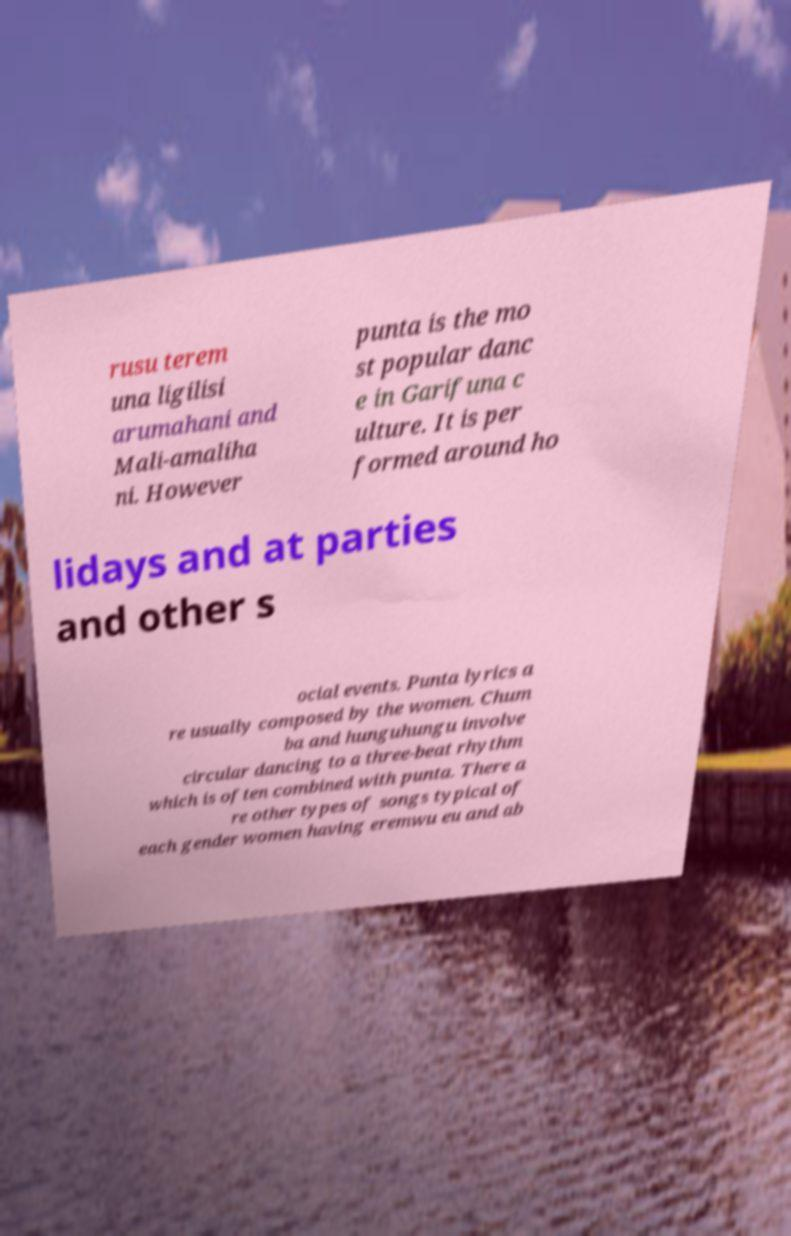There's text embedded in this image that I need extracted. Can you transcribe it verbatim? rusu terem una ligilisi arumahani and Mali-amaliha ni. However punta is the mo st popular danc e in Garifuna c ulture. It is per formed around ho lidays and at parties and other s ocial events. Punta lyrics a re usually composed by the women. Chum ba and hunguhungu involve circular dancing to a three-beat rhythm which is often combined with punta. There a re other types of songs typical of each gender women having eremwu eu and ab 